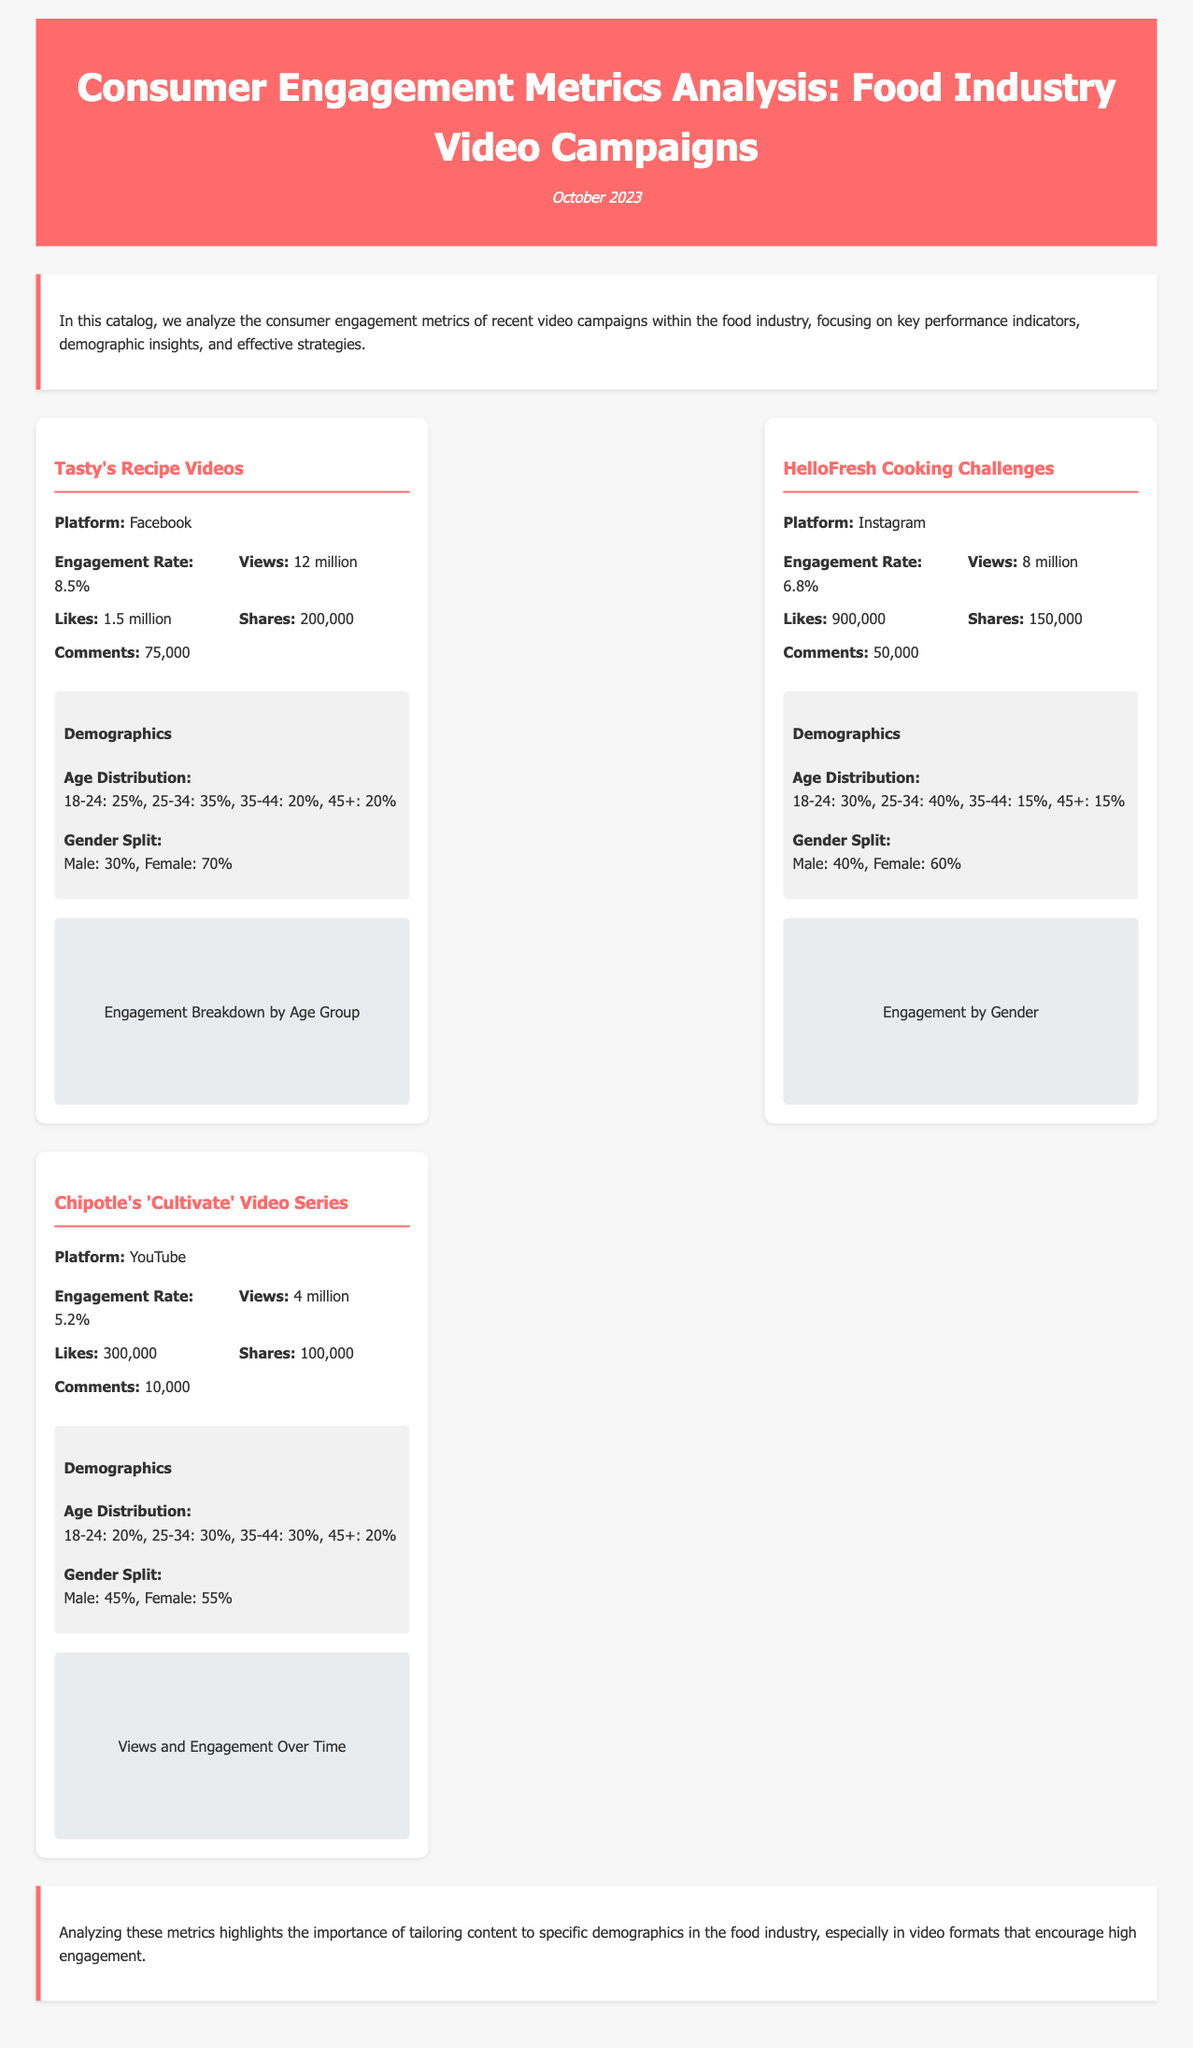what is the engagement rate for Tasty's Recipe Videos? The engagement rate for Tasty's Recipe Videos is specifically mentioned in the document.
Answer: 8.5% how many views did the HelloFresh Cooking Challenges receive? The number of views for the HelloFresh Cooking Challenges is stated in the metrics section.
Answer: 8 million what is the gender split for Chipotle's 'Cultivate' Video Series? The gender split for Chipotle's campaign is detailed in the demographics section.
Answer: Male: 45%, Female: 55% which platform had the highest engagement rate among the campaigns? This requires comparing the engagement rates from all listed campaigns to identify the highest.
Answer: Facebook what is the age distribution percentage for 25-34 age group in HelloFresh Cooking Challenges? This information is explicitly listed in the demographics section for HelloFresh.
Answer: 40% which campaign had the lowest number of comments? Comparing the number of comments across all campaigns reveals which is the lowest.
Answer: Chipotle's 'Cultivate' Video Series what is the total number of shares for Tasty's Recipe Videos? The total number of shares is clearly stated in the metrics section.
Answer: 200,000 what is emphasized in the conclusion regarding content creation? The conclusion summarizes the key insight based on the metrics analyzed in the document.
Answer: Tailoring content to specific demographics 